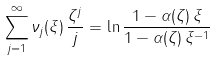<formula> <loc_0><loc_0><loc_500><loc_500>\sum _ { j = 1 } ^ { \infty } \nu _ { j } ( \xi ) \, \frac { \zeta ^ { j } } { j } = \ln \frac { 1 - \alpha ( \zeta ) \, \xi } { 1 - \alpha ( \zeta ) \, \xi ^ { - 1 } }</formula> 